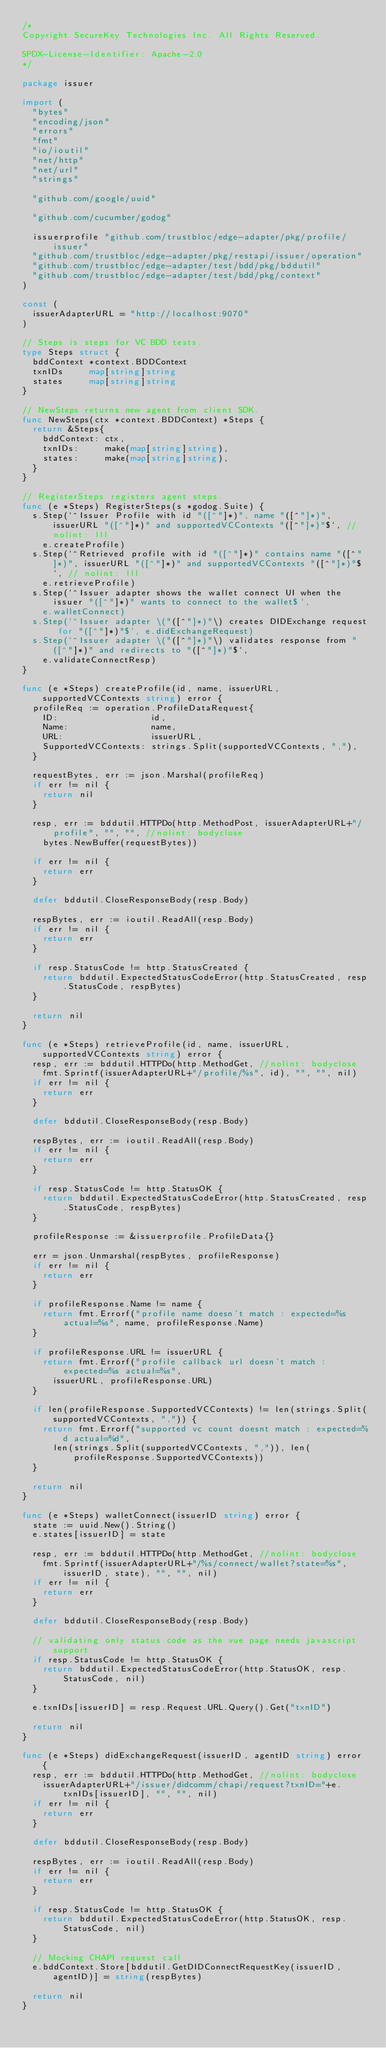Convert code to text. <code><loc_0><loc_0><loc_500><loc_500><_Go_>/*
Copyright SecureKey Technologies Inc. All Rights Reserved.

SPDX-License-Identifier: Apache-2.0
*/

package issuer

import (
	"bytes"
	"encoding/json"
	"errors"
	"fmt"
	"io/ioutil"
	"net/http"
	"net/url"
	"strings"

	"github.com/google/uuid"

	"github.com/cucumber/godog"

	issuerprofile "github.com/trustbloc/edge-adapter/pkg/profile/issuer"
	"github.com/trustbloc/edge-adapter/pkg/restapi/issuer/operation"
	"github.com/trustbloc/edge-adapter/test/bdd/pkg/bddutil"
	"github.com/trustbloc/edge-adapter/test/bdd/pkg/context"
)

const (
	issuerAdapterURL = "http://localhost:9070"
)

// Steps is steps for VC BDD tests.
type Steps struct {
	bddContext *context.BDDContext
	txnIDs     map[string]string
	states     map[string]string
}

// NewSteps returns new agent from client SDK.
func NewSteps(ctx *context.BDDContext) *Steps {
	return &Steps{
		bddContext: ctx,
		txnIDs:     make(map[string]string),
		states:     make(map[string]string),
	}
}

// RegisterSteps registers agent steps.
func (e *Steps) RegisterSteps(s *godog.Suite) {
	s.Step(`^Issuer Profile with id "([^"]*)", name "([^"]*)", issuerURL "([^"]*)" and supportedVCContexts "([^"]*)"$`, // nolint: lll
		e.createProfile)
	s.Step(`^Retrieved profile with id "([^"]*)" contains name "([^"]*)", issuerURL "([^"]*)" and supportedVCContexts "([^"]*)"$`, // nolint: lll
		e.retrieveProfile)
	s.Step(`^Issuer adapter shows the wallet connect UI when the issuer "([^"]*)" wants to connect to the wallet$`,
		e.walletConnect)
	s.Step(`^Issuer adapter \("([^"]*)"\) creates DIDExchange request for "([^"]*)"$`, e.didExchangeRequest)
	s.Step(`^Issuer adapter \("([^"]*)"\) validates response from "([^"]*)" and redirects to "([^"]*)"$`,
		e.validateConnectResp)
}

func (e *Steps) createProfile(id, name, issuerURL, supportedVCContexts string) error {
	profileReq := operation.ProfileDataRequest{
		ID:                  id,
		Name:                name,
		URL:                 issuerURL,
		SupportedVCContexts: strings.Split(supportedVCContexts, ","),
	}

	requestBytes, err := json.Marshal(profileReq)
	if err != nil {
		return nil
	}

	resp, err := bddutil.HTTPDo(http.MethodPost, issuerAdapterURL+"/profile", "", "", //nolint: bodyclose
		bytes.NewBuffer(requestBytes))

	if err != nil {
		return err
	}

	defer bddutil.CloseResponseBody(resp.Body)

	respBytes, err := ioutil.ReadAll(resp.Body)
	if err != nil {
		return err
	}

	if resp.StatusCode != http.StatusCreated {
		return bddutil.ExpectedStatusCodeError(http.StatusCreated, resp.StatusCode, respBytes)
	}

	return nil
}

func (e *Steps) retrieveProfile(id, name, issuerURL, supportedVCContexts string) error {
	resp, err := bddutil.HTTPDo(http.MethodGet, //nolint: bodyclose
		fmt.Sprintf(issuerAdapterURL+"/profile/%s", id), "", "", nil)
	if err != nil {
		return err
	}

	defer bddutil.CloseResponseBody(resp.Body)

	respBytes, err := ioutil.ReadAll(resp.Body)
	if err != nil {
		return err
	}

	if resp.StatusCode != http.StatusOK {
		return bddutil.ExpectedStatusCodeError(http.StatusCreated, resp.StatusCode, respBytes)
	}

	profileResponse := &issuerprofile.ProfileData{}

	err = json.Unmarshal(respBytes, profileResponse)
	if err != nil {
		return err
	}

	if profileResponse.Name != name {
		return fmt.Errorf("profile name doesn't match : expected=%s actual=%s", name, profileResponse.Name)
	}

	if profileResponse.URL != issuerURL {
		return fmt.Errorf("profile callback url doesn't match : expected=%s actual=%s",
			issuerURL, profileResponse.URL)
	}

	if len(profileResponse.SupportedVCContexts) != len(strings.Split(supportedVCContexts, ",")) {
		return fmt.Errorf("supported vc count doesnt match : expected=%d actual=%d",
			len(strings.Split(supportedVCContexts, ",")), len(profileResponse.SupportedVCContexts))
	}

	return nil
}

func (e *Steps) walletConnect(issuerID string) error {
	state := uuid.New().String()
	e.states[issuerID] = state

	resp, err := bddutil.HTTPDo(http.MethodGet, //nolint: bodyclose
		fmt.Sprintf(issuerAdapterURL+"/%s/connect/wallet?state=%s", issuerID, state), "", "", nil)
	if err != nil {
		return err
	}

	defer bddutil.CloseResponseBody(resp.Body)

	// validating only status code as the vue page needs javascript support
	if resp.StatusCode != http.StatusOK {
		return bddutil.ExpectedStatusCodeError(http.StatusOK, resp.StatusCode, nil)
	}

	e.txnIDs[issuerID] = resp.Request.URL.Query().Get("txnID")

	return nil
}

func (e *Steps) didExchangeRequest(issuerID, agentID string) error {
	resp, err := bddutil.HTTPDo(http.MethodGet, //nolint: bodyclose
		issuerAdapterURL+"/issuer/didcomm/chapi/request?txnID="+e.txnIDs[issuerID], "", "", nil)
	if err != nil {
		return err
	}

	defer bddutil.CloseResponseBody(resp.Body)

	respBytes, err := ioutil.ReadAll(resp.Body)
	if err != nil {
		return err
	}

	if resp.StatusCode != http.StatusOK {
		return bddutil.ExpectedStatusCodeError(http.StatusOK, resp.StatusCode, nil)
	}

	// Mocking CHAPI request call
	e.bddContext.Store[bddutil.GetDIDConnectRequestKey(issuerID, agentID)] = string(respBytes)

	return nil
}
</code> 